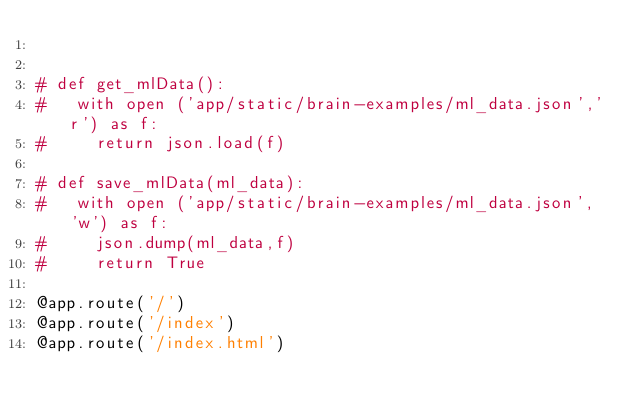<code> <loc_0><loc_0><loc_500><loc_500><_Python_>

# def get_mlData():
#   with open ('app/static/brain-examples/ml_data.json','r') as f:
#     return json.load(f)

# def save_mlData(ml_data):
#   with open ('app/static/brain-examples/ml_data.json', 'w') as f:
#     json.dump(ml_data,f)
#     return True

@app.route('/')
@app.route('/index')
@app.route('/index.html')</code> 